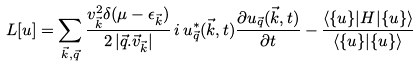<formula> <loc_0><loc_0><loc_500><loc_500>L [ u ] = \sum _ { \vec { k } , \vec { q } } \frac { v _ { \vec { k } } ^ { 2 } \delta ( \mu - \epsilon _ { \vec { k } } ) } { 2 \, | \vec { q } . \vec { v } _ { \vec { k } } | } \, i \, u ^ { \ast } _ { \vec { q } } ( \vec { k } , t ) \frac { \partial u _ { \vec { q } } ( \vec { k } , t ) } { \partial t } - \frac { \langle \{ u \} | H | \{ u \} \rangle } { \langle \{ u \} | \{ u \} \rangle }</formula> 